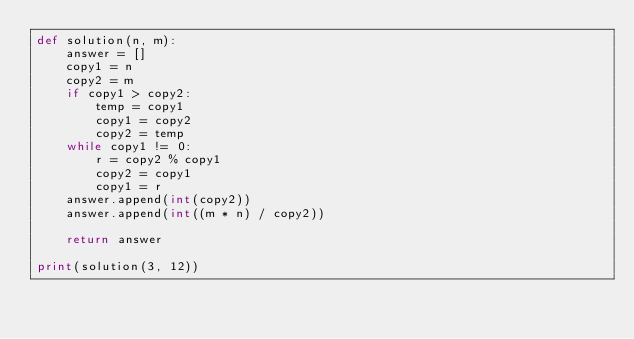<code> <loc_0><loc_0><loc_500><loc_500><_Python_>def solution(n, m):
    answer = []
    copy1 = n
    copy2 = m
    if copy1 > copy2:
        temp = copy1
        copy1 = copy2
        copy2 = temp
    while copy1 != 0:
        r = copy2 % copy1
        copy2 = copy1
        copy1 = r
    answer.append(int(copy2))
    answer.append(int((m * n) / copy2))

    return answer

print(solution(3, 12))</code> 